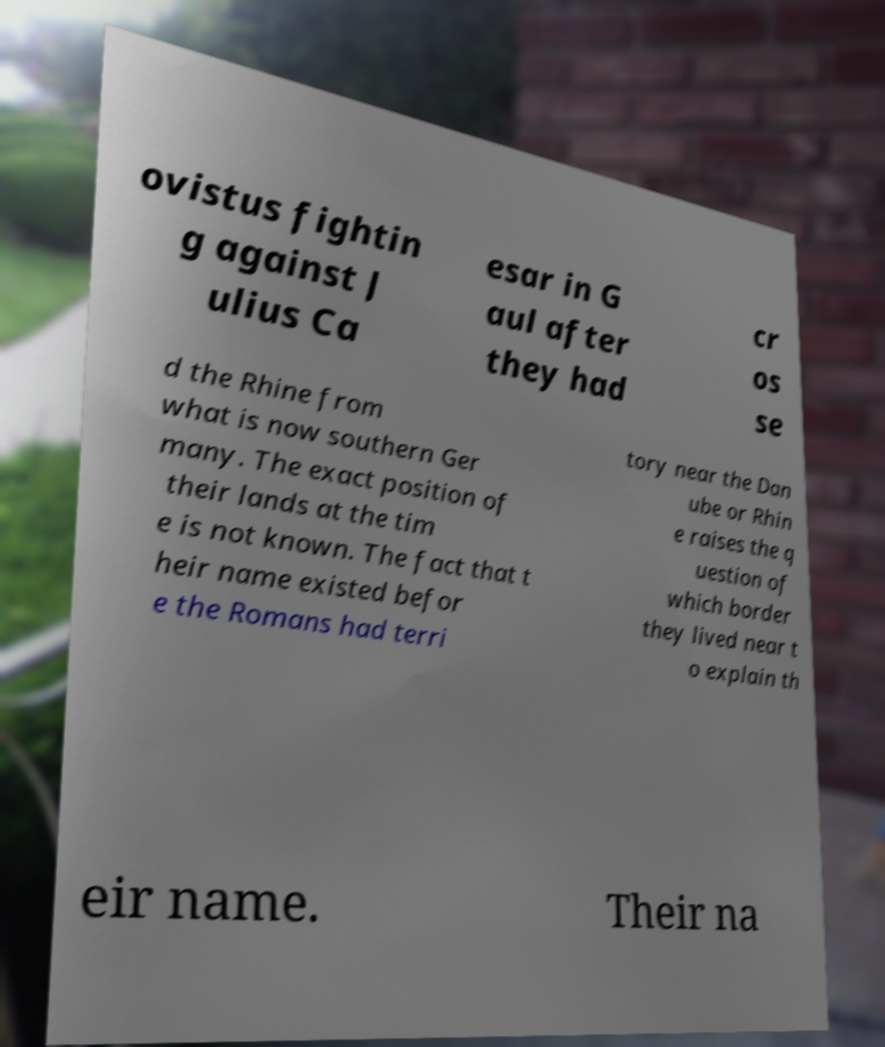Can you read and provide the text displayed in the image?This photo seems to have some interesting text. Can you extract and type it out for me? ovistus fightin g against J ulius Ca esar in G aul after they had cr os se d the Rhine from what is now southern Ger many. The exact position of their lands at the tim e is not known. The fact that t heir name existed befor e the Romans had terri tory near the Dan ube or Rhin e raises the q uestion of which border they lived near t o explain th eir name. Their na 